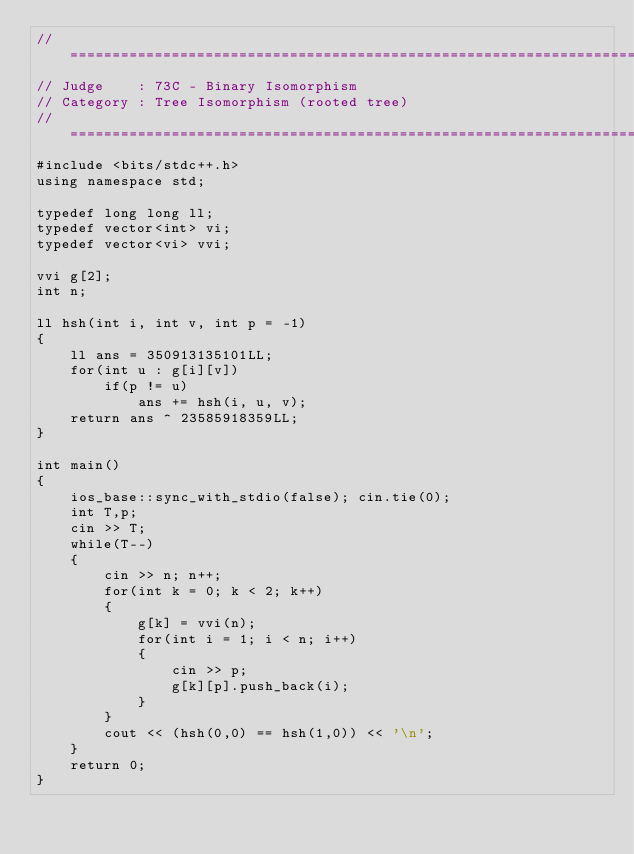<code> <loc_0><loc_0><loc_500><loc_500><_C++_>//============================================================================
// Judge    : 73C - Binary Isomorphism
// Category : Tree Isomorphism (rooted tree)
//============================================================================
#include <bits/stdc++.h>
using namespace std;

typedef long long ll;
typedef vector<int> vi;
typedef vector<vi> vvi;

vvi g[2];
int n;

ll hsh(int i, int v, int p = -1)
{
    ll ans = 350913135101LL;
    for(int u : g[i][v])
        if(p != u)
            ans += hsh(i, u, v);
    return ans ^ 23585918359LL;
}

int main()
{
    ios_base::sync_with_stdio(false); cin.tie(0);
    int T,p;
    cin >> T;
    while(T--)
    {
        cin >> n; n++;
        for(int k = 0; k < 2; k++)
        {
            g[k] = vvi(n);
            for(int i = 1; i < n; i++)
            {
                cin >> p;
                g[k][p].push_back(i);
            }
        }
        cout << (hsh(0,0) == hsh(1,0)) << '\n';
    }
    return 0;
}</code> 